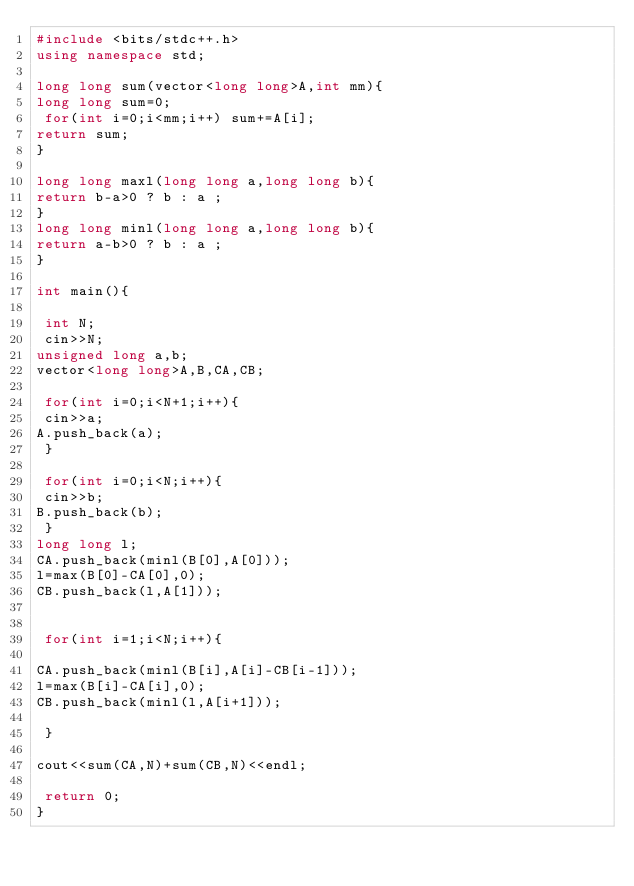Convert code to text. <code><loc_0><loc_0><loc_500><loc_500><_C++_>#include <bits/stdc++.h>
using namespace std;

long long sum(vector<long long>A,int mm){
long long sum=0;
 for(int i=0;i<mm;i++) sum+=A[i];
return sum;
}

long long maxl(long long a,long long b){
return b-a>0 ? b : a ;
}
long long minl(long long a,long long b){
return a-b>0 ? b : a ;
}

int main(){

 int N;
 cin>>N;
unsigned long a,b;
vector<long long>A,B,CA,CB;

 for(int i=0;i<N+1;i++){
 cin>>a;
A.push_back(a);
 }

 for(int i=0;i<N;i++){
 cin>>b;
B.push_back(b);
 }
long long l;
CA.push_back(minl(B[0],A[0]));
l=max(B[0]-CA[0],0);
CB.push_back(l,A[1]));


 for(int i=1;i<N;i++){

CA.push_back(minl(B[i],A[i]-CB[i-1]));
l=max(B[i]-CA[i],0);
CB.push_back(minl(l,A[i+1]));

 }

cout<<sum(CA,N)+sum(CB,N)<<endl;

 return 0;
}</code> 